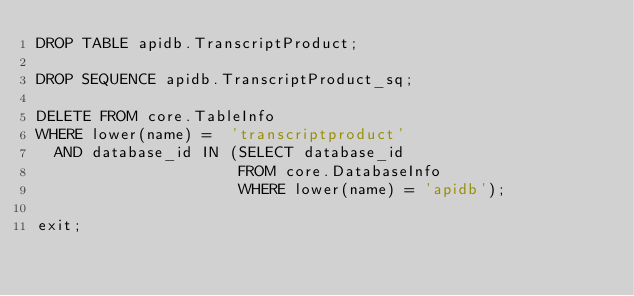<code> <loc_0><loc_0><loc_500><loc_500><_SQL_>DROP TABLE apidb.TranscriptProduct;

DROP SEQUENCE apidb.TranscriptProduct_sq;

DELETE FROM core.TableInfo
WHERE lower(name) =  'transcriptproduct'
  AND database_id IN (SELECT database_id
                      FROM core.DatabaseInfo
                      WHERE lower(name) = 'apidb');

exit;
</code> 